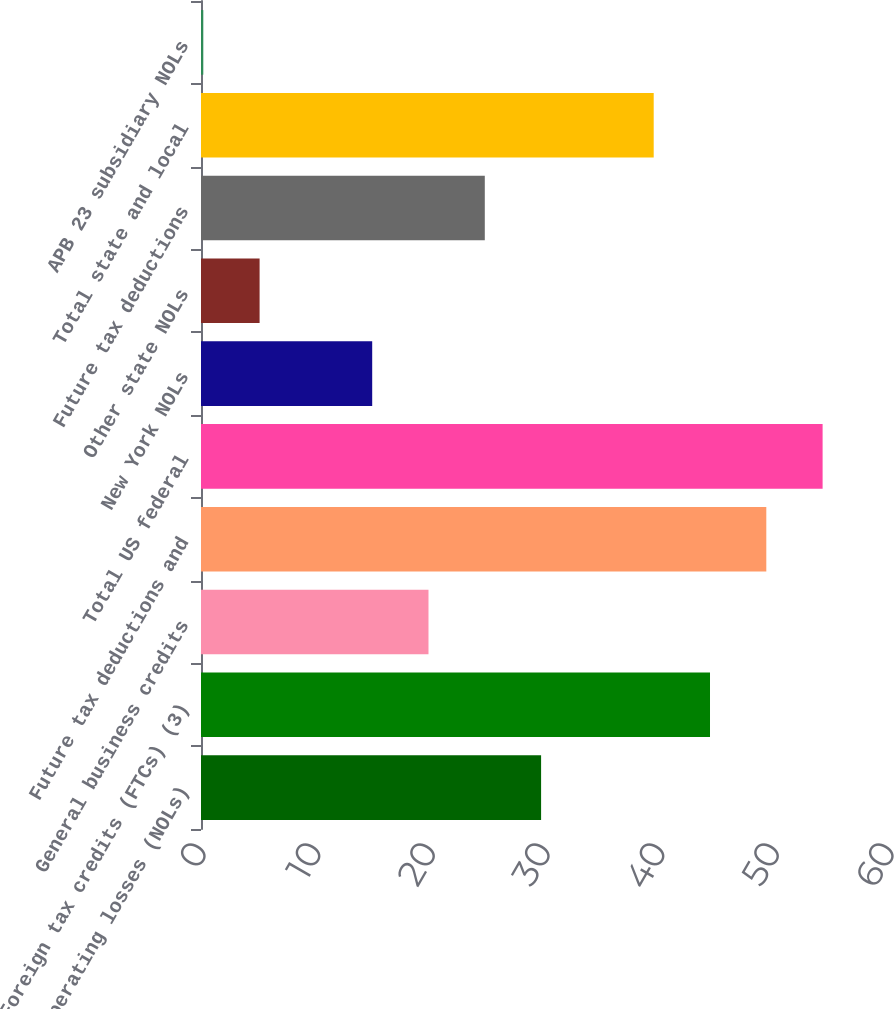<chart> <loc_0><loc_0><loc_500><loc_500><bar_chart><fcel>Net operating losses (NOLs)<fcel>Foreign tax credits (FTCs) (3)<fcel>General business credits<fcel>Future tax deductions and<fcel>Total US federal<fcel>New York NOLs<fcel>Other state NOLs<fcel>Future tax deductions<fcel>Total state and local<fcel>APB 23 subsidiary NOLs<nl><fcel>29.66<fcel>44.39<fcel>19.84<fcel>49.3<fcel>54.21<fcel>14.93<fcel>5.11<fcel>24.75<fcel>39.48<fcel>0.2<nl></chart> 